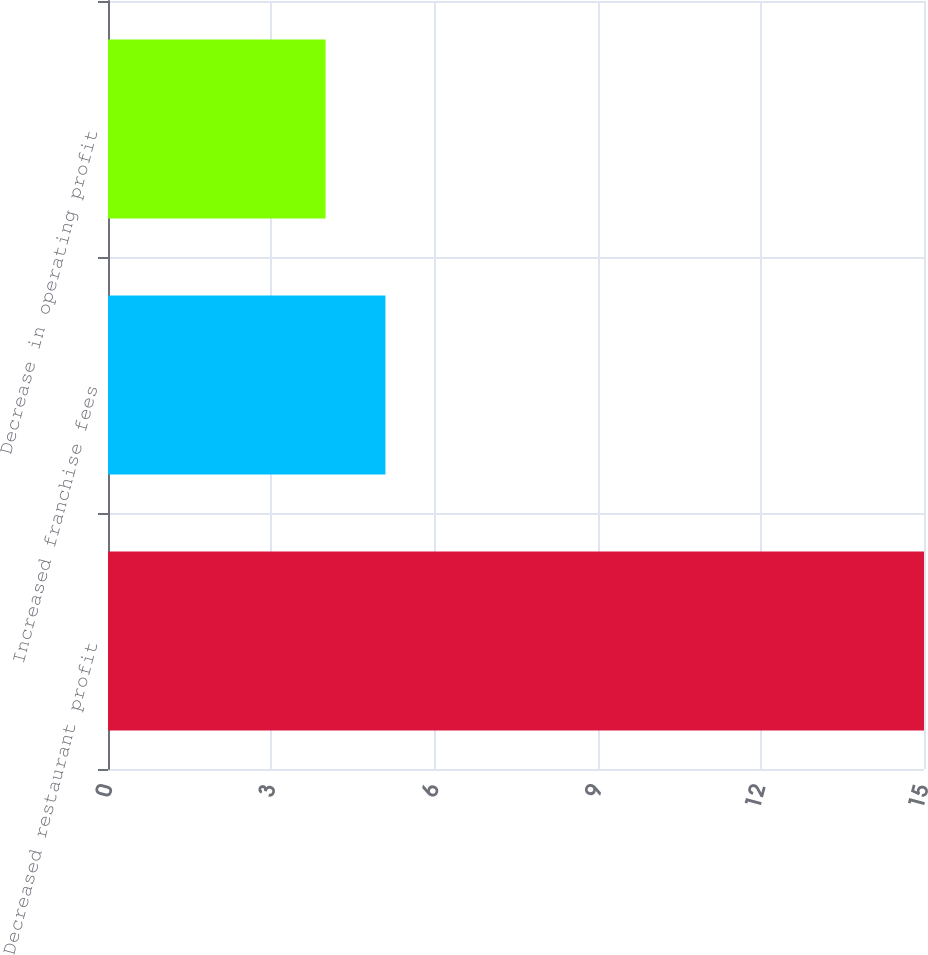Convert chart. <chart><loc_0><loc_0><loc_500><loc_500><bar_chart><fcel>Decreased restaurant profit<fcel>Increased franchise fees<fcel>Decrease in operating profit<nl><fcel>15<fcel>5.1<fcel>4<nl></chart> 